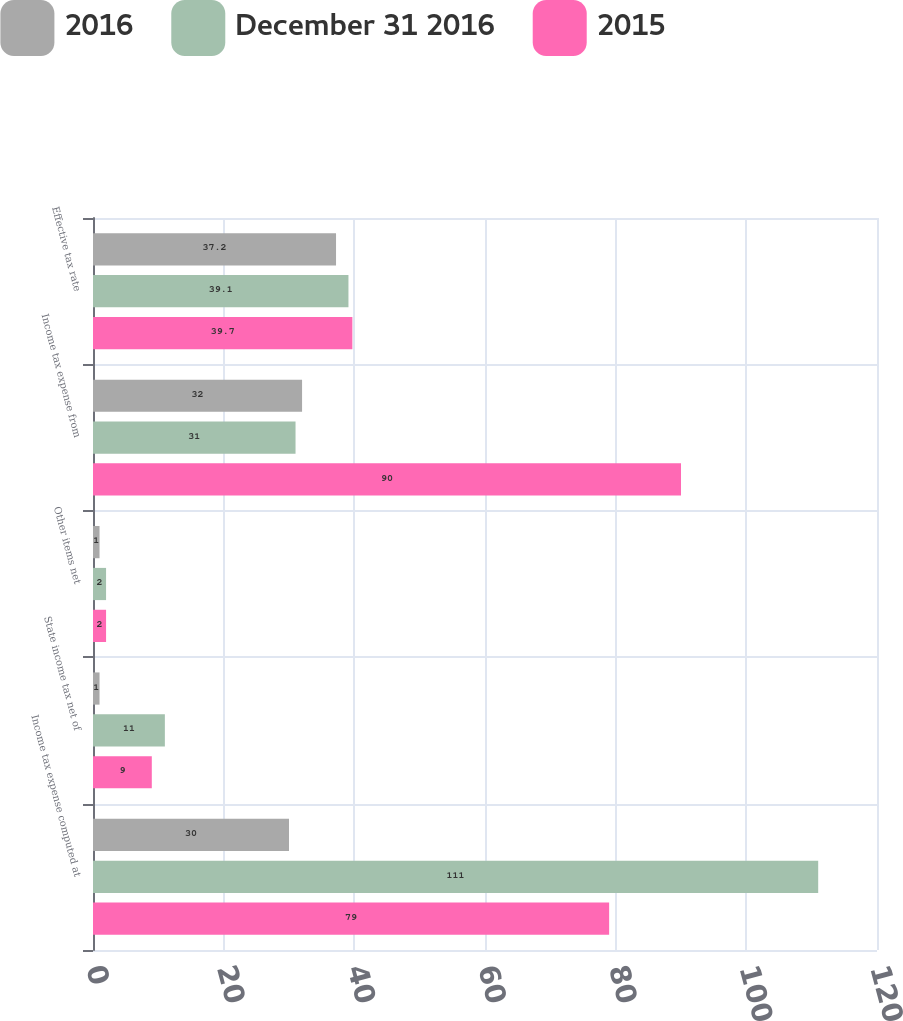Convert chart. <chart><loc_0><loc_0><loc_500><loc_500><stacked_bar_chart><ecel><fcel>Income tax expense computed at<fcel>State income tax net of<fcel>Other items net<fcel>Income tax expense from<fcel>Effective tax rate<nl><fcel>2016<fcel>30<fcel>1<fcel>1<fcel>32<fcel>37.2<nl><fcel>December 31 2016<fcel>111<fcel>11<fcel>2<fcel>31<fcel>39.1<nl><fcel>2015<fcel>79<fcel>9<fcel>2<fcel>90<fcel>39.7<nl></chart> 